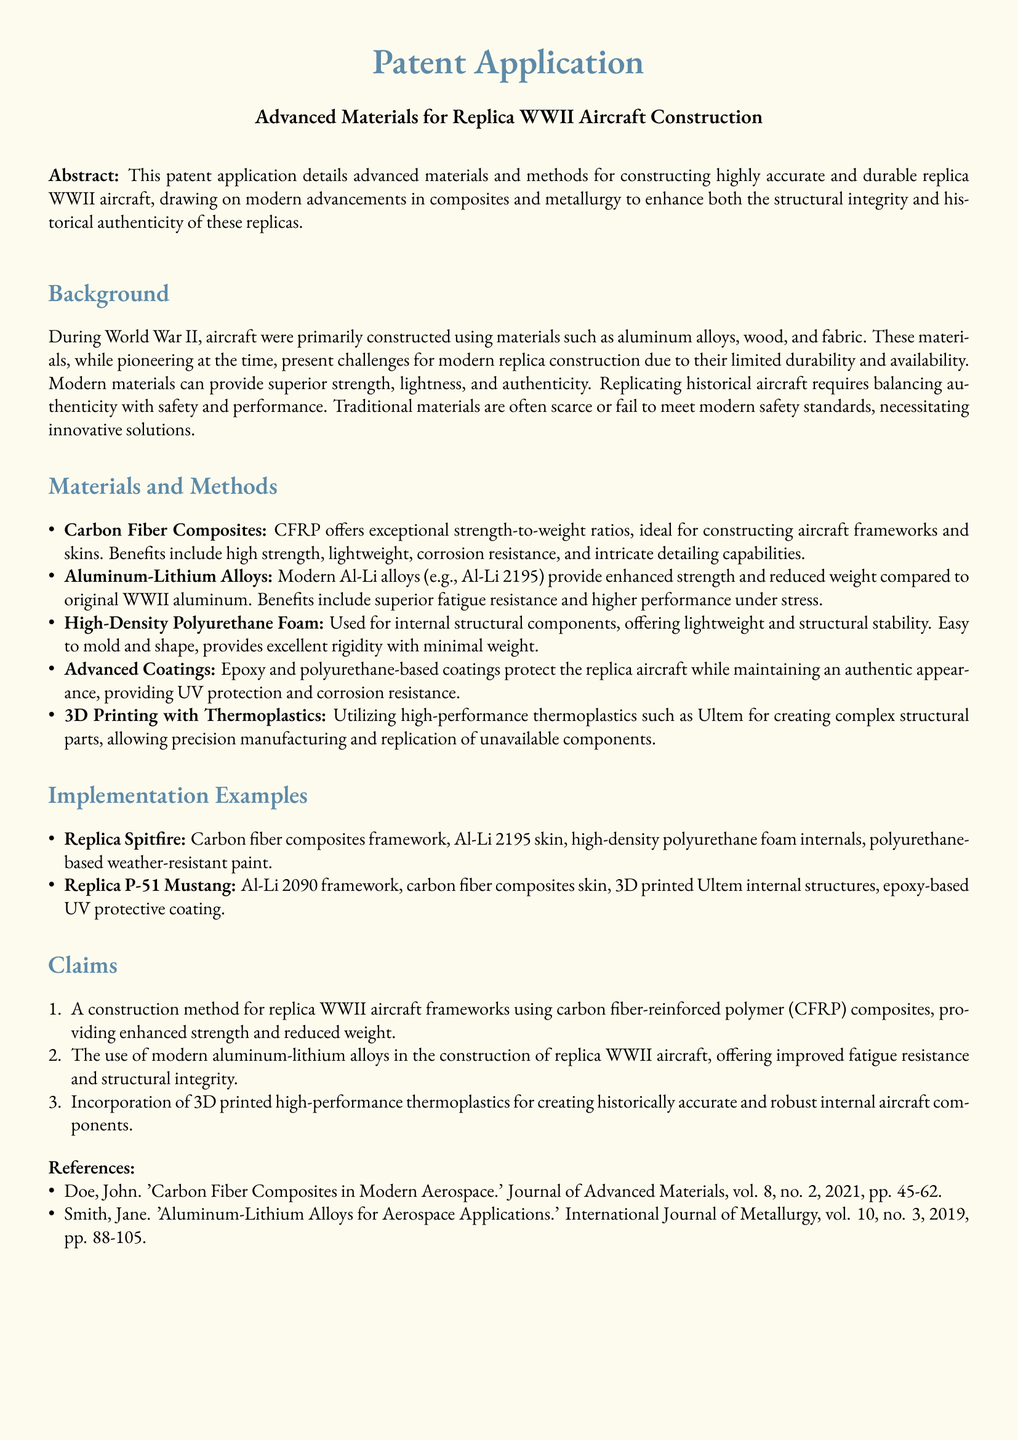What is the title of the patent application? The title is found in the header of the document describing the focus of the application.
Answer: Advanced Materials for Replica WWII Aircraft Construction What is the primary benefit of carbon fiber composites? This benefit is detailed under the materials section, highlighting the advantages of the material used for aircraft.
Answer: Exceptional strength-to-weight ratios What is one of the materials used for internal structural components? The document lists specific materials in the methods section for various applications.
Answer: High-Density Polyurethane Foam Which aircraft is mentioned as a replica example using carbon fiber composites? This information is found in the implementation examples section, specifying the aircraft types constructed.
Answer: Replica Spitfire How many claims are listed in the patent application? The claims are outlined in a numbered list which indicates the unique aspects being patented.
Answer: Three What kind of coatings are used for the replica aircraft? The document provides information in the materials and methods section regarding protective layers used.
Answer: Epoxy and polyurethane-based coatings What modern alloy is specifically mentioned in the claims? The claims section refers to materials used in construction, highlighting specific advancements.
Answer: Aluminum-Lithium Alloys Who is the author of one of the references? The references section lists the authors of the cited literature, which supports the claims made in the document.
Answer: John Doe What is the application of 3D printing in the construction process? This is stated in the claims and methods sections, describing the technology's role in part creation.
Answer: Creating complex structural parts 